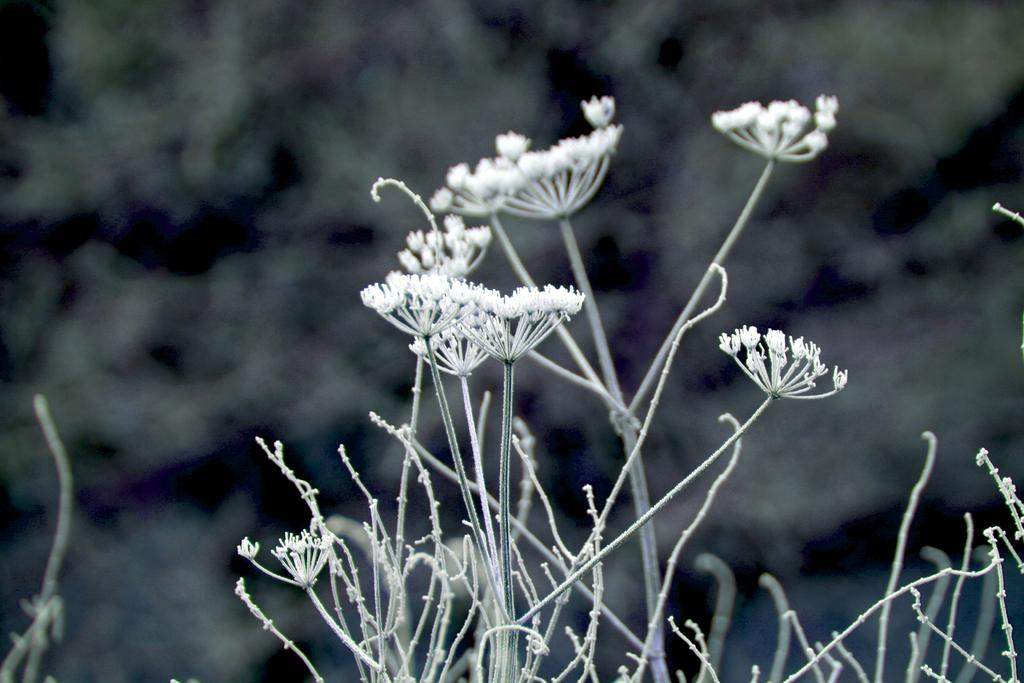What type of living organisms can be seen in the image? Plants can be seen in the image. What specific feature can be observed on the plants? The plants have tiny flowers. Can you describe the background of the image? The background of the image appears blurry. What type of bread can be seen in the image? There is no bread present in the image; it features plants with tiny flowers. 